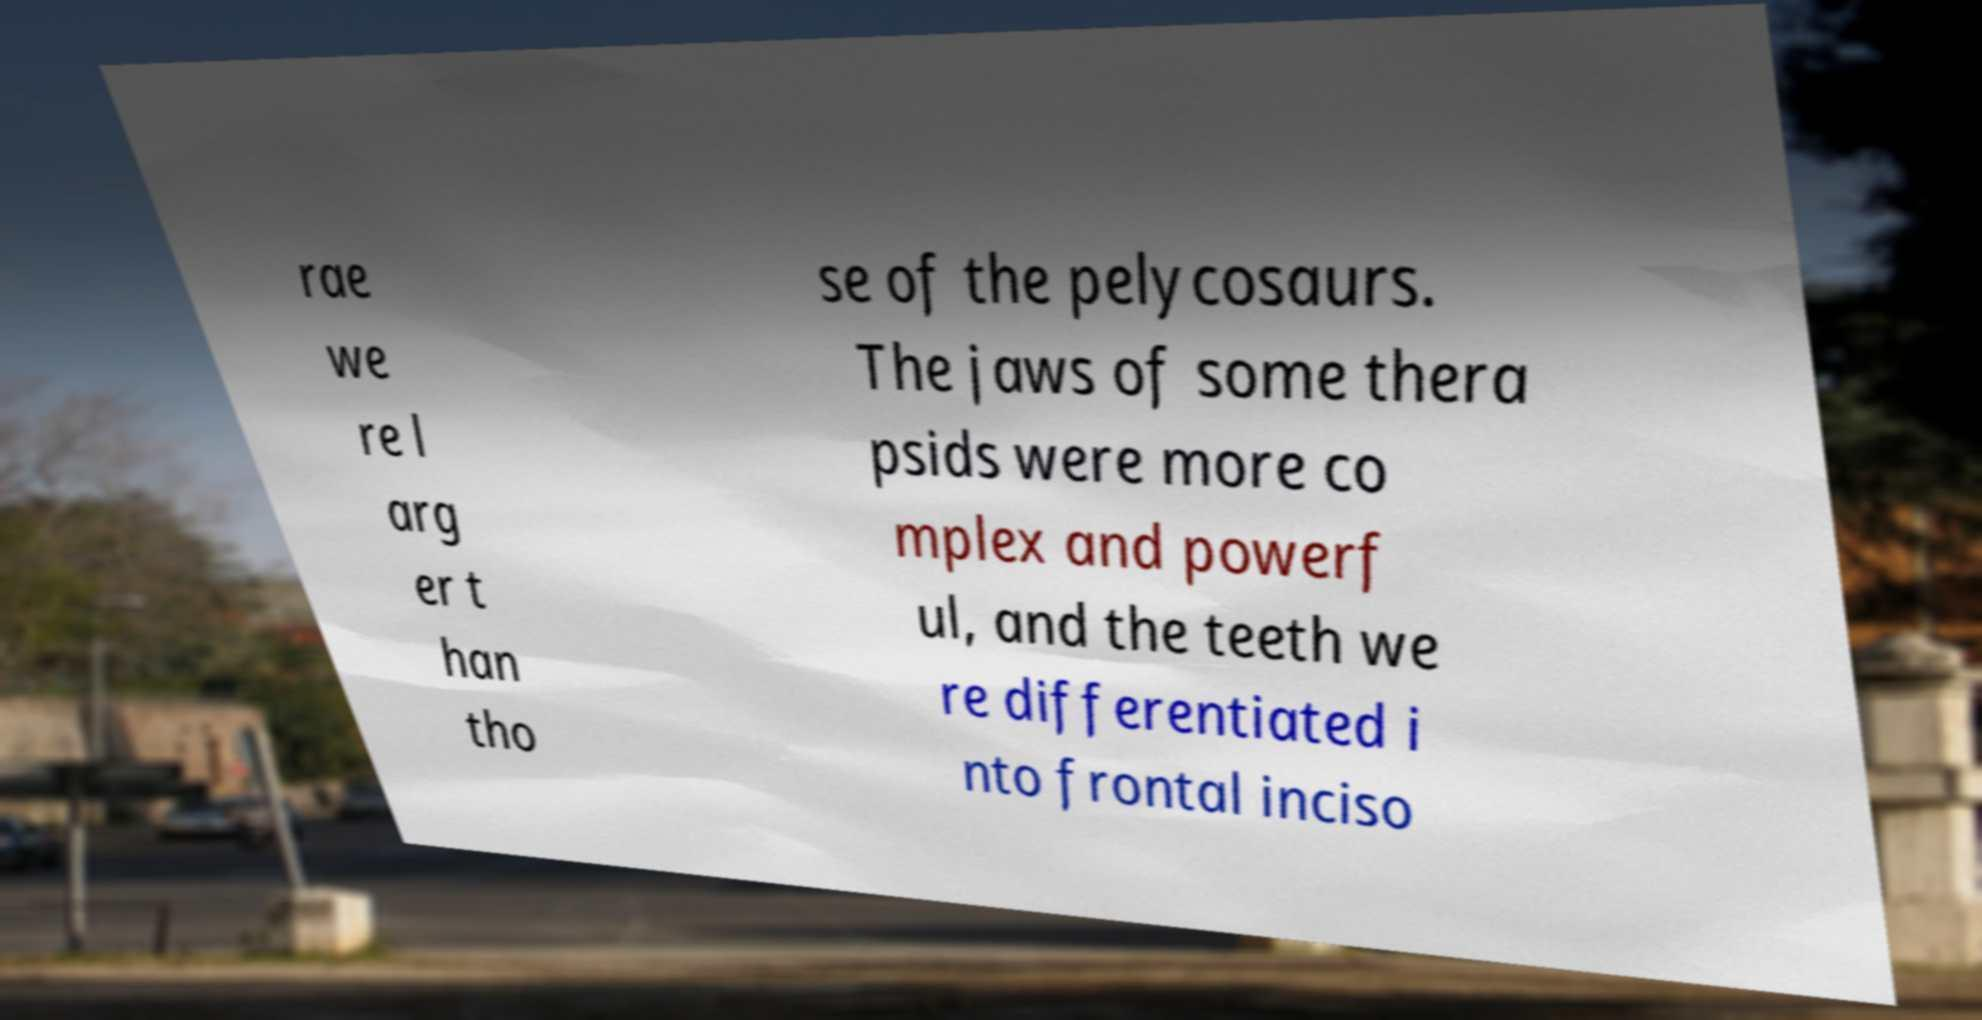Could you extract and type out the text from this image? rae we re l arg er t han tho se of the pelycosaurs. The jaws of some thera psids were more co mplex and powerf ul, and the teeth we re differentiated i nto frontal inciso 